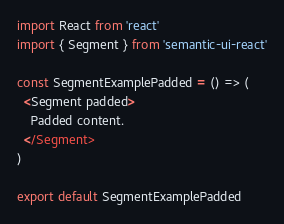Convert code to text. <code><loc_0><loc_0><loc_500><loc_500><_JavaScript_>import React from 'react'
import { Segment } from 'semantic-ui-react'

const SegmentExamplePadded = () => (
  <Segment padded>
    Padded content.
  </Segment>
)

export default SegmentExamplePadded
</code> 